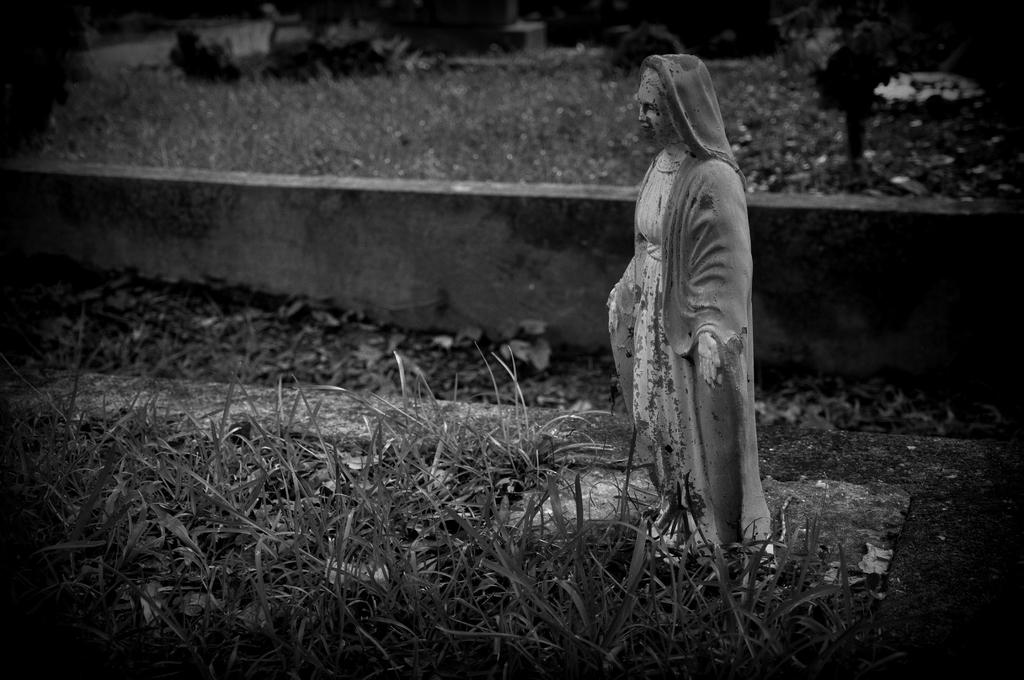What is the main subject in the image? There is a statue in the image. What is located behind the statue? There is a wall in the image. What type of natural environment is visible in the image? There is grass in the image. What type of blade is being used by the statue in the image? There is no blade present in the image, as the statue is not holding or using any tool or weapon. 